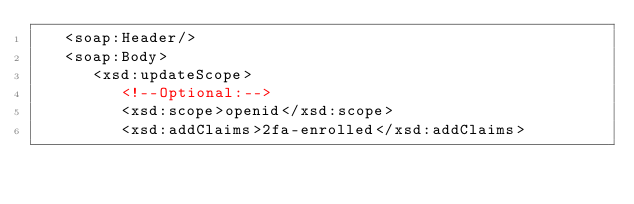Convert code to text. <code><loc_0><loc_0><loc_500><loc_500><_XML_>   <soap:Header/>
   <soap:Body>
      <xsd:updateScope>
         <!--Optional:-->
         <xsd:scope>openid</xsd:scope>
         <xsd:addClaims>2fa-enrolled</xsd:addClaims></code> 